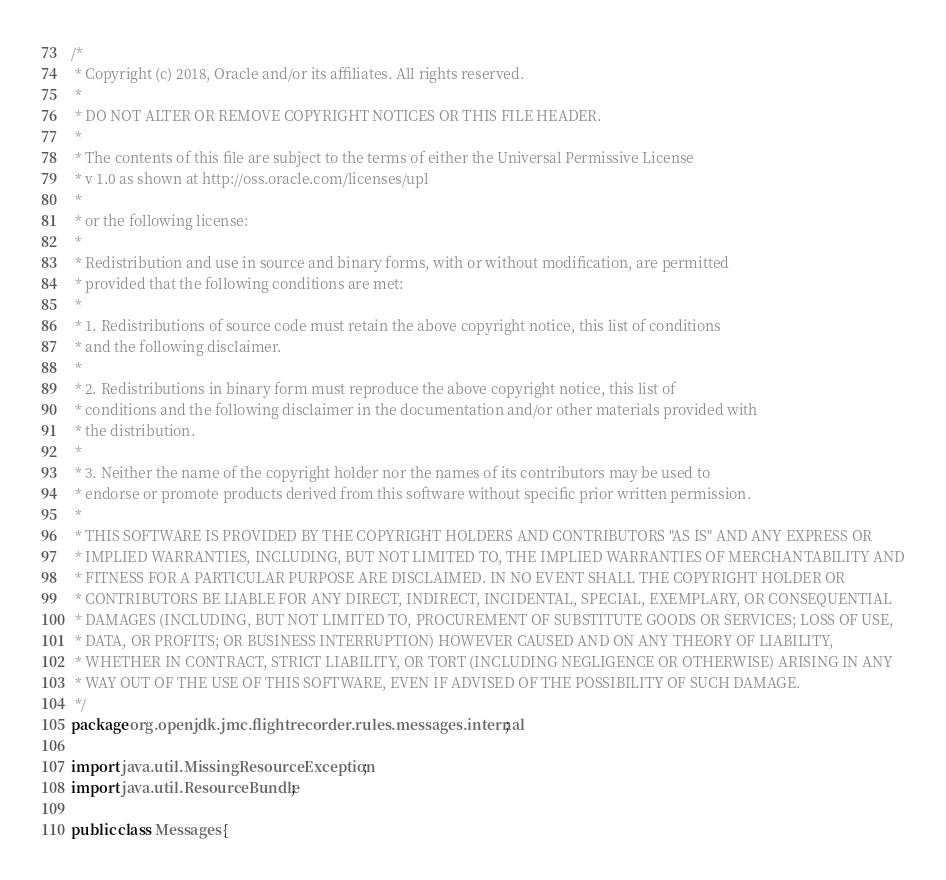Convert code to text. <code><loc_0><loc_0><loc_500><loc_500><_Java_>/*
 * Copyright (c) 2018, Oracle and/or its affiliates. All rights reserved.
 * 
 * DO NOT ALTER OR REMOVE COPYRIGHT NOTICES OR THIS FILE HEADER.
 *
 * The contents of this file are subject to the terms of either the Universal Permissive License
 * v 1.0 as shown at http://oss.oracle.com/licenses/upl
 *
 * or the following license:
 *
 * Redistribution and use in source and binary forms, with or without modification, are permitted
 * provided that the following conditions are met:
 * 
 * 1. Redistributions of source code must retain the above copyright notice, this list of conditions
 * and the following disclaimer.
 * 
 * 2. Redistributions in binary form must reproduce the above copyright notice, this list of
 * conditions and the following disclaimer in the documentation and/or other materials provided with
 * the distribution.
 * 
 * 3. Neither the name of the copyright holder nor the names of its contributors may be used to
 * endorse or promote products derived from this software without specific prior written permission.
 * 
 * THIS SOFTWARE IS PROVIDED BY THE COPYRIGHT HOLDERS AND CONTRIBUTORS "AS IS" AND ANY EXPRESS OR
 * IMPLIED WARRANTIES, INCLUDING, BUT NOT LIMITED TO, THE IMPLIED WARRANTIES OF MERCHANTABILITY AND
 * FITNESS FOR A PARTICULAR PURPOSE ARE DISCLAIMED. IN NO EVENT SHALL THE COPYRIGHT HOLDER OR
 * CONTRIBUTORS BE LIABLE FOR ANY DIRECT, INDIRECT, INCIDENTAL, SPECIAL, EXEMPLARY, OR CONSEQUENTIAL
 * DAMAGES (INCLUDING, BUT NOT LIMITED TO, PROCUREMENT OF SUBSTITUTE GOODS OR SERVICES; LOSS OF USE,
 * DATA, OR PROFITS; OR BUSINESS INTERRUPTION) HOWEVER CAUSED AND ON ANY THEORY OF LIABILITY,
 * WHETHER IN CONTRACT, STRICT LIABILITY, OR TORT (INCLUDING NEGLIGENCE OR OTHERWISE) ARISING IN ANY
 * WAY OUT OF THE USE OF THIS SOFTWARE, EVEN IF ADVISED OF THE POSSIBILITY OF SUCH DAMAGE.
 */
package org.openjdk.jmc.flightrecorder.rules.messages.internal;

import java.util.MissingResourceException;
import java.util.ResourceBundle;

public class Messages {</code> 